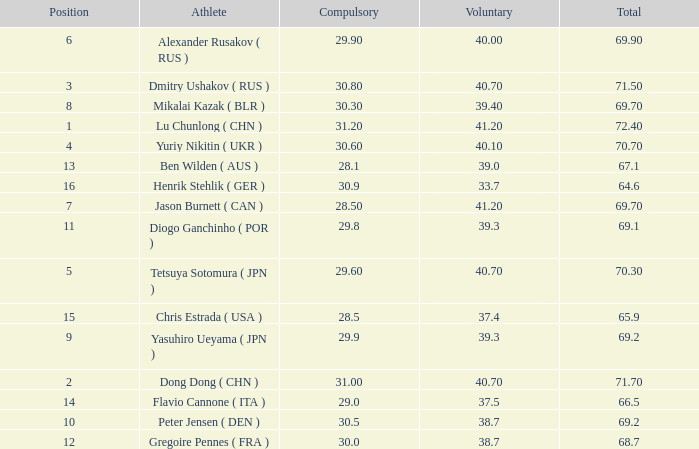What's the position that has a total less than 66.5m, a compulsory of 30.9 and voluntary less than 33.7? None. 